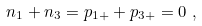<formula> <loc_0><loc_0><loc_500><loc_500>n _ { 1 } + n _ { 3 } = p _ { 1 + } + p _ { 3 + } = 0 \text { } ,</formula> 